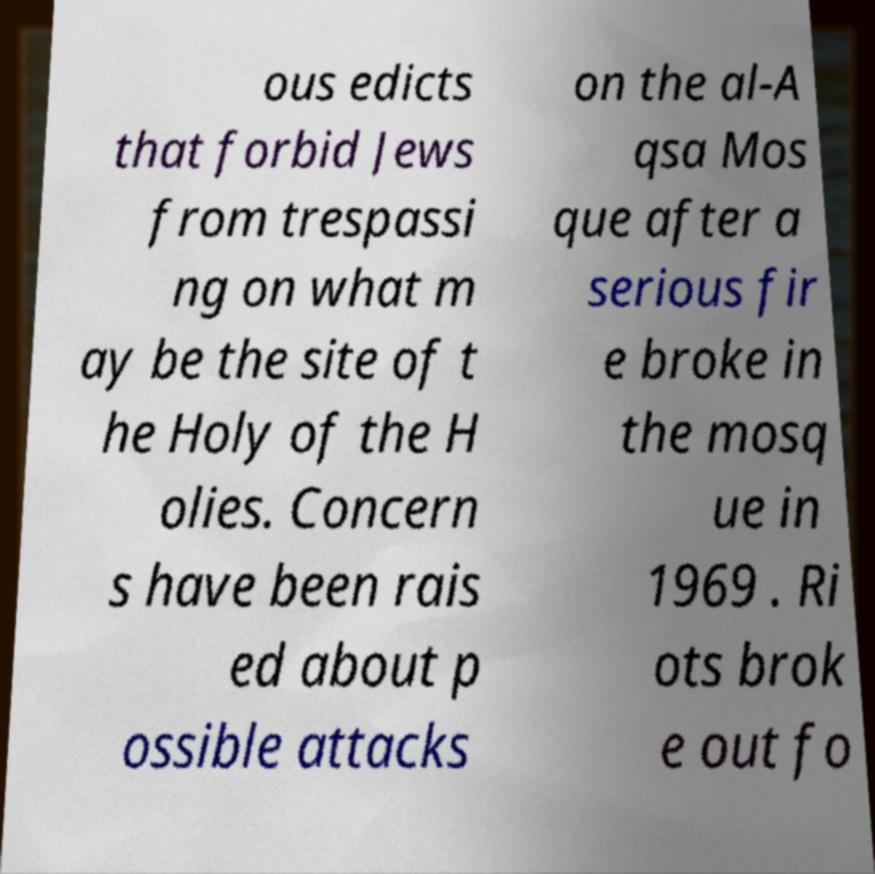Can you accurately transcribe the text from the provided image for me? ous edicts that forbid Jews from trespassi ng on what m ay be the site of t he Holy of the H olies. Concern s have been rais ed about p ossible attacks on the al-A qsa Mos que after a serious fir e broke in the mosq ue in 1969 . Ri ots brok e out fo 